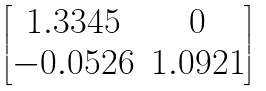<formula> <loc_0><loc_0><loc_500><loc_500>\begin{bmatrix} 1 . 3 3 4 5 & 0 \\ - 0 . 0 5 2 6 & 1 . 0 9 2 1 \end{bmatrix}</formula> 